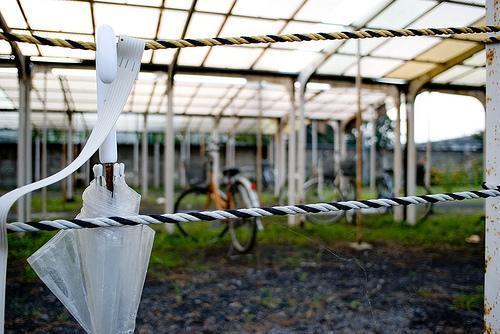How many umbrellas are there?
Give a very brief answer. 1. How many chairs have blue blankets on them?
Give a very brief answer. 0. 